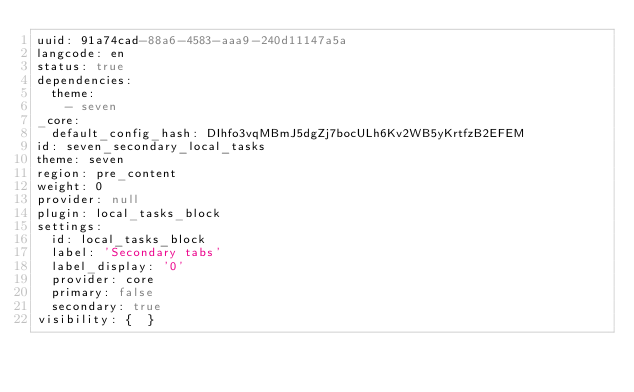<code> <loc_0><loc_0><loc_500><loc_500><_YAML_>uuid: 91a74cad-88a6-4583-aaa9-240d11147a5a
langcode: en
status: true
dependencies:
  theme:
    - seven
_core:
  default_config_hash: DIhfo3vqMBmJ5dgZj7bocULh6Kv2WB5yKrtfzB2EFEM
id: seven_secondary_local_tasks
theme: seven
region: pre_content
weight: 0
provider: null
plugin: local_tasks_block
settings:
  id: local_tasks_block
  label: 'Secondary tabs'
  label_display: '0'
  provider: core
  primary: false
  secondary: true
visibility: {  }
</code> 